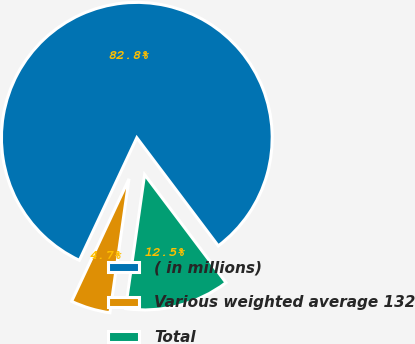Convert chart to OTSL. <chart><loc_0><loc_0><loc_500><loc_500><pie_chart><fcel>( in millions)<fcel>Various weighted average 132<fcel>Total<nl><fcel>82.75%<fcel>4.72%<fcel>12.53%<nl></chart> 